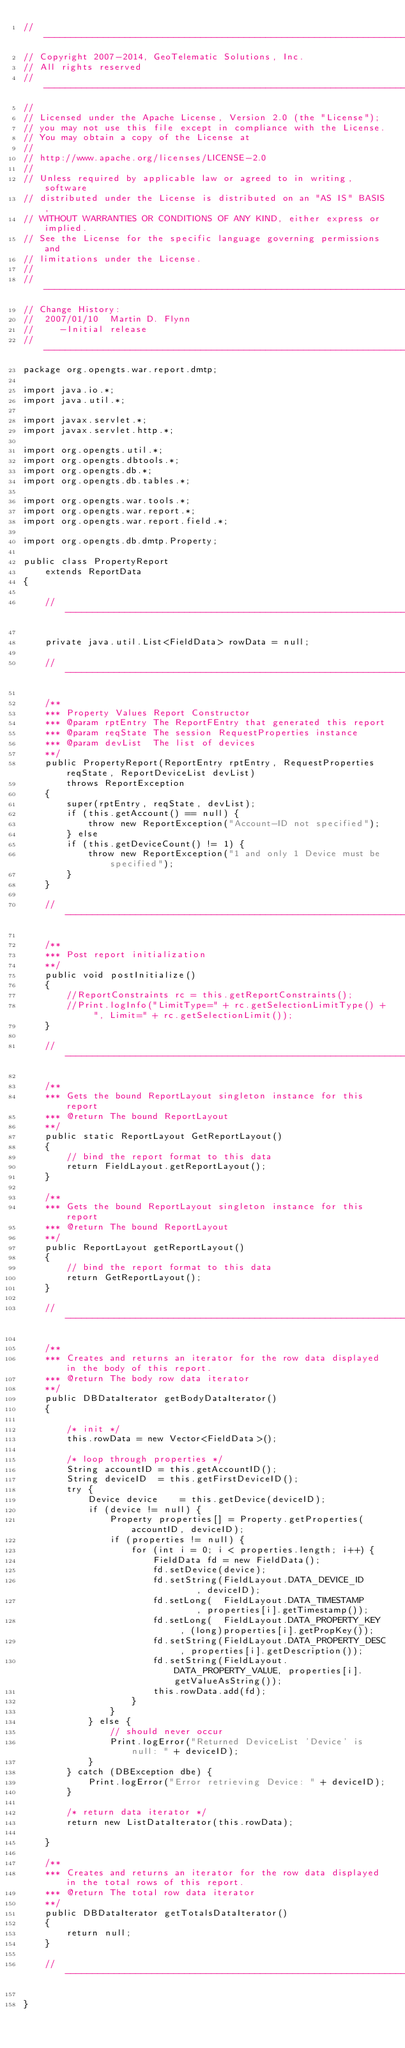<code> <loc_0><loc_0><loc_500><loc_500><_Java_>// ----------------------------------------------------------------------------
// Copyright 2007-2014, GeoTelematic Solutions, Inc.
// All rights reserved
// ----------------------------------------------------------------------------
//
// Licensed under the Apache License, Version 2.0 (the "License");
// you may not use this file except in compliance with the License.
// You may obtain a copy of the License at
// 
// http://www.apache.org/licenses/LICENSE-2.0
// 
// Unless required by applicable law or agreed to in writing, software
// distributed under the License is distributed on an "AS IS" BASIS,
// WITHOUT WARRANTIES OR CONDITIONS OF ANY KIND, either express or implied.
// See the License for the specific language governing permissions and
// limitations under the License.
//
// ----------------------------------------------------------------------------
// Change History:
//  2007/01/10  Martin D. Flynn
//     -Initial release
// ----------------------------------------------------------------------------
package org.opengts.war.report.dmtp;

import java.io.*;
import java.util.*;

import javax.servlet.*;
import javax.servlet.http.*;

import org.opengts.util.*;
import org.opengts.dbtools.*;
import org.opengts.db.*;
import org.opengts.db.tables.*;

import org.opengts.war.tools.*;
import org.opengts.war.report.*;
import org.opengts.war.report.field.*;

import org.opengts.db.dmtp.Property;

public class PropertyReport
    extends ReportData
{

    // ------------------------------------------------------------------------

    private java.util.List<FieldData> rowData = null;

    // ------------------------------------------------------------------------

    /**
    *** Property Values Report Constructor
    *** @param rptEntry The ReportFEntry that generated this report
    *** @param reqState The session RequestProperties instance
    *** @param devList  The list of devices
    **/
    public PropertyReport(ReportEntry rptEntry, RequestProperties reqState, ReportDeviceList devList)
        throws ReportException
    {
        super(rptEntry, reqState, devList);
        if (this.getAccount() == null) {
            throw new ReportException("Account-ID not specified");
        } else
        if (this.getDeviceCount() != 1) {
            throw new ReportException("1 and only 1 Device must be specified");
        }
    }

    // ------------------------------------------------------------------------

    /**
    *** Post report initialization
    **/
    public void postInitialize()
    {
        //ReportConstraints rc = this.getReportConstraints();
        //Print.logInfo("LimitType=" + rc.getSelectionLimitType() + ", Limit=" + rc.getSelectionLimit());
    }

    // ------------------------------------------------------------------------

    /**
    *** Gets the bound ReportLayout singleton instance for this report
    *** @return The bound ReportLayout
    **/
    public static ReportLayout GetReportLayout()
    {
        // bind the report format to this data
        return FieldLayout.getReportLayout();
    }

    /**
    *** Gets the bound ReportLayout singleton instance for this report
    *** @return The bound ReportLayout
    **/
    public ReportLayout getReportLayout()
    {
        // bind the report format to this data
        return GetReportLayout();
    }

    // ------------------------------------------------------------------------

    /**
    *** Creates and returns an iterator for the row data displayed in the body of this report.
    *** @return The body row data iterator
    **/
    public DBDataIterator getBodyDataIterator()
    {
        
        /* init */
        this.rowData = new Vector<FieldData>();
        
        /* loop through properties */
        String accountID = this.getAccountID();
        String deviceID  = this.getFirstDeviceID();
        try {
            Device device    = this.getDevice(deviceID);
            if (device != null) {
                Property properties[] = Property.getProperties(accountID, deviceID);
                if (properties != null) {
                    for (int i = 0; i < properties.length; i++) {
                        FieldData fd = new FieldData();
                        fd.setDevice(device);
                        fd.setString(FieldLayout.DATA_DEVICE_ID     , deviceID);
                        fd.setLong(  FieldLayout.DATA_TIMESTAMP     , properties[i].getTimestamp());
                        fd.setLong(  FieldLayout.DATA_PROPERTY_KEY  , (long)properties[i].getPropKey());
                        fd.setString(FieldLayout.DATA_PROPERTY_DESC , properties[i].getDescription());
                        fd.setString(FieldLayout.DATA_PROPERTY_VALUE, properties[i].getValueAsString());
                        this.rowData.add(fd);
                    }
                }
            } else {
                // should never occur
                Print.logError("Returned DeviceList 'Device' is null: " + deviceID);
            }
        } catch (DBException dbe) {
            Print.logError("Error retrieving Device: " + deviceID);
        }

        /* return data iterator */
        return new ListDataIterator(this.rowData);
        
    }

    /**
    *** Creates and returns an iterator for the row data displayed in the total rows of this report.
    *** @return The total row data iterator
    **/
    public DBDataIterator getTotalsDataIterator()
    {
        return null;
    }

    // ------------------------------------------------------------------------

}
</code> 